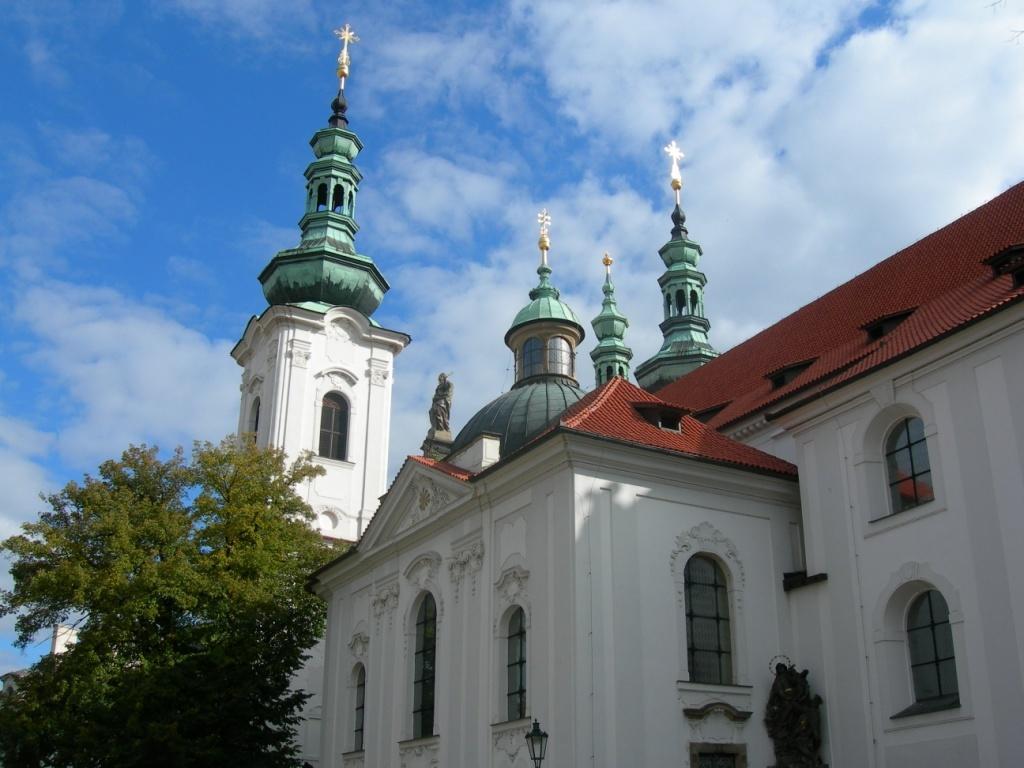In one or two sentences, can you explain what this image depicts? In this image I can see a building,windows,light-pole and trees. The sky is in blue and white color. 